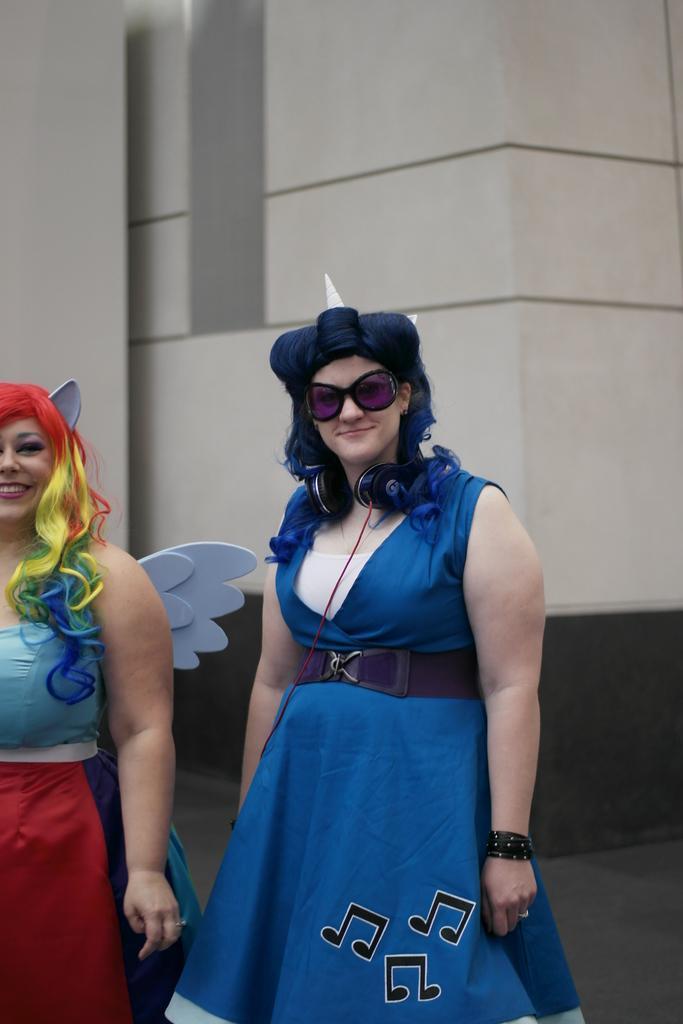Could you give a brief overview of what you see in this image? In this image we can see two ladies. One lady is wearing goggles and having headphones on the neck. In the back there is a wall. 